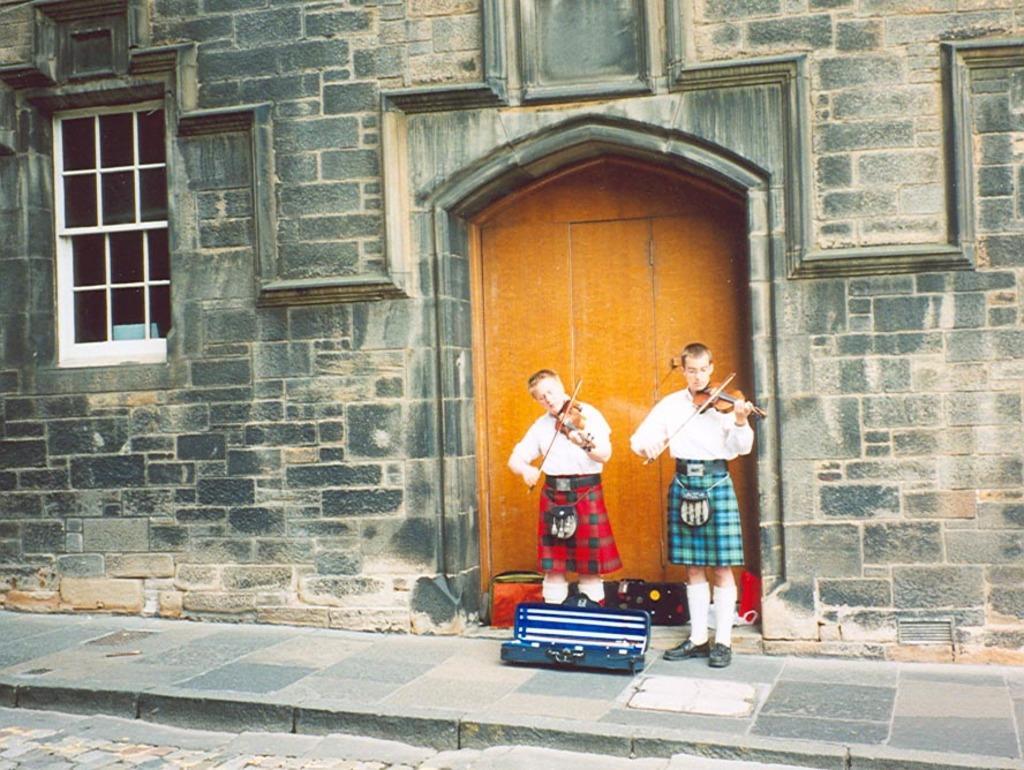Describe this image in one or two sentences. This picture is clicked outside. In the center we can see the two persons wearing white color shirts and standing and playing violins and we can see there are some objects placed on the ground. In the background we can see the window and the door of the building. 